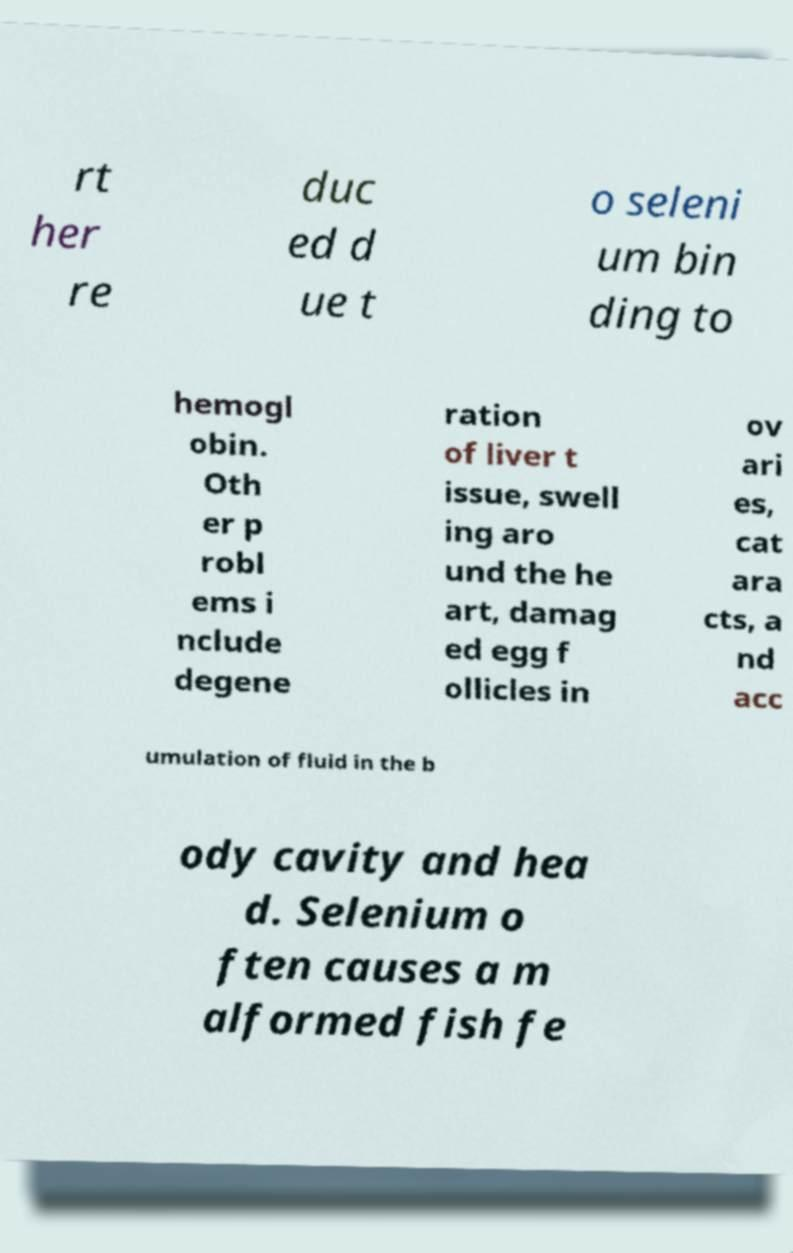Please read and relay the text visible in this image. What does it say? rt her re duc ed d ue t o seleni um bin ding to hemogl obin. Oth er p robl ems i nclude degene ration of liver t issue, swell ing aro und the he art, damag ed egg f ollicles in ov ari es, cat ara cts, a nd acc umulation of fluid in the b ody cavity and hea d. Selenium o ften causes a m alformed fish fe 